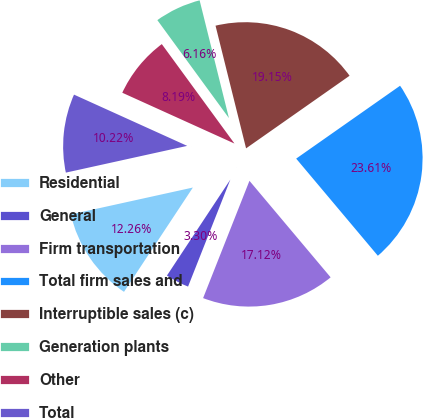<chart> <loc_0><loc_0><loc_500><loc_500><pie_chart><fcel>Residential<fcel>General<fcel>Firm transportation<fcel>Total firm sales and<fcel>Interruptible sales (c)<fcel>Generation plants<fcel>Other<fcel>Total<nl><fcel>12.26%<fcel>3.3%<fcel>17.12%<fcel>23.61%<fcel>19.15%<fcel>6.16%<fcel>8.19%<fcel>10.22%<nl></chart> 